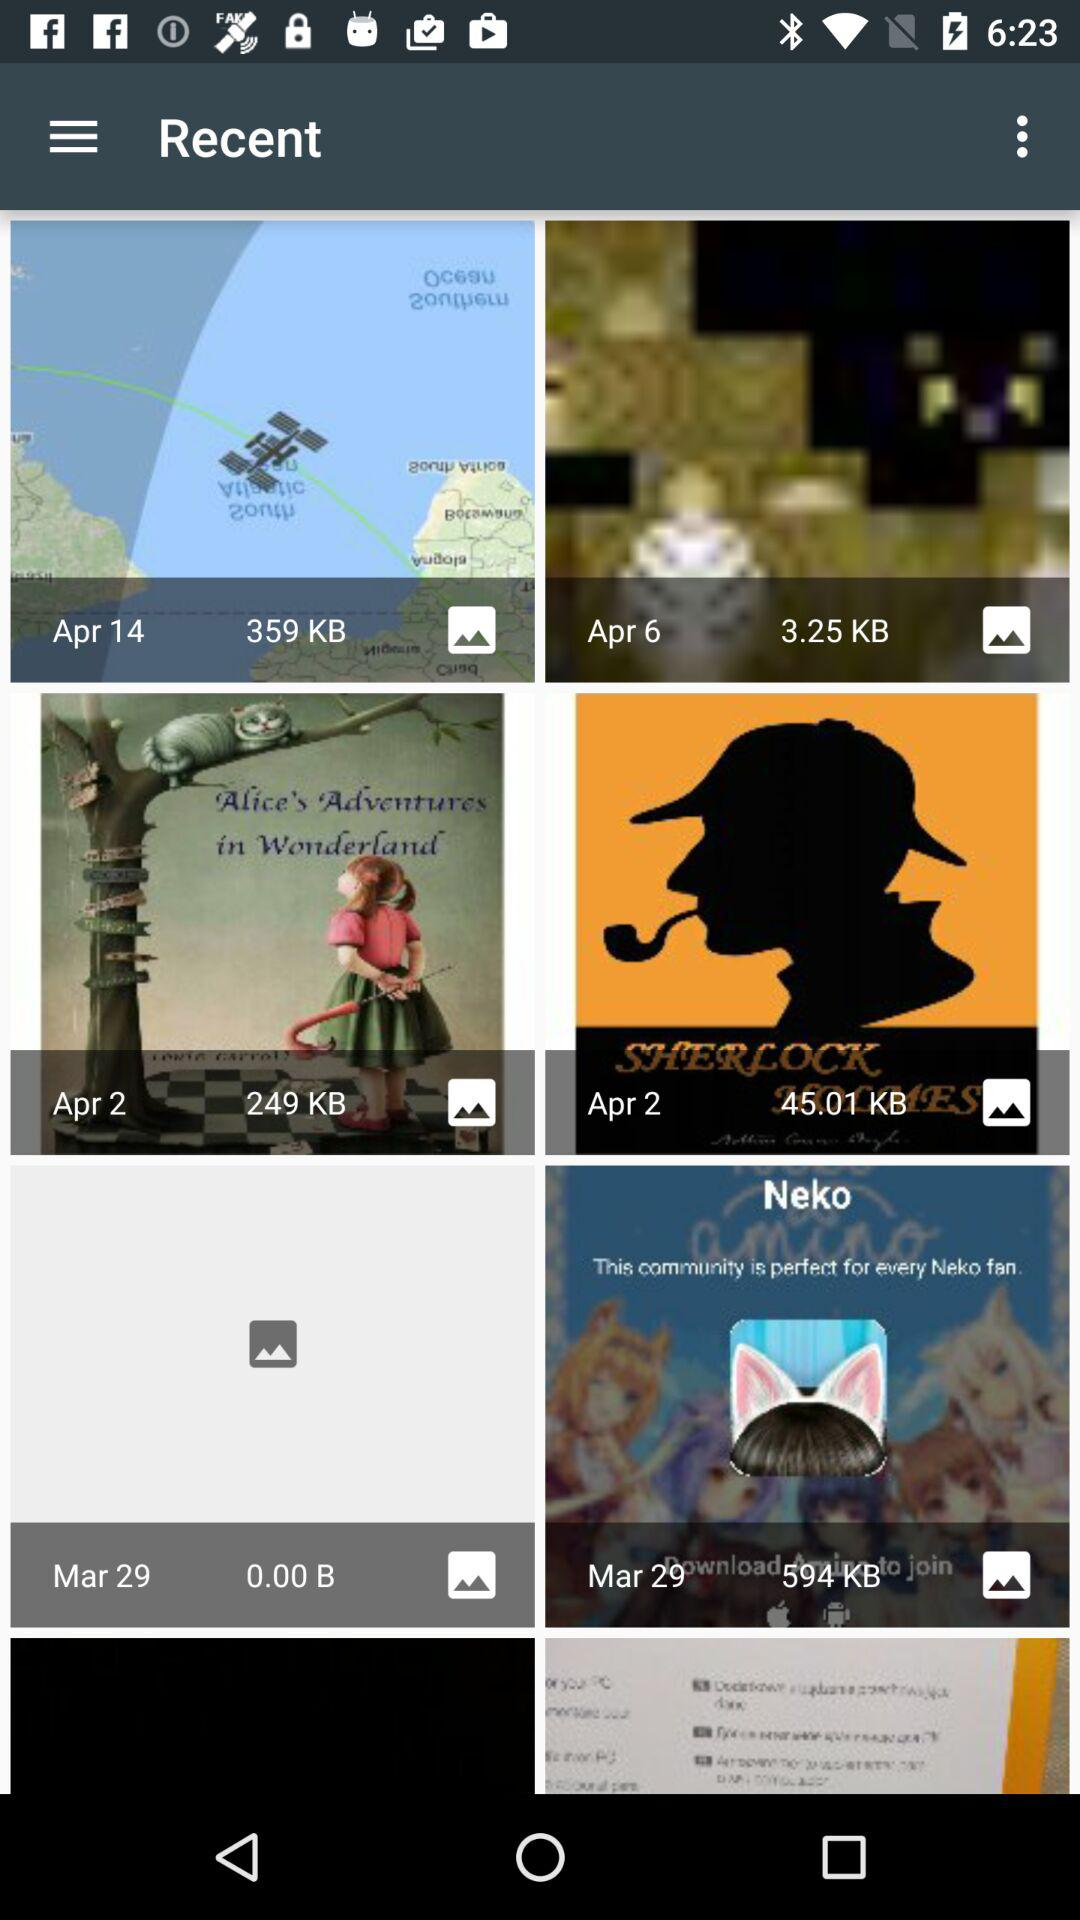What is the size of the image taken on April 14? The size of the image is 359 KB. 